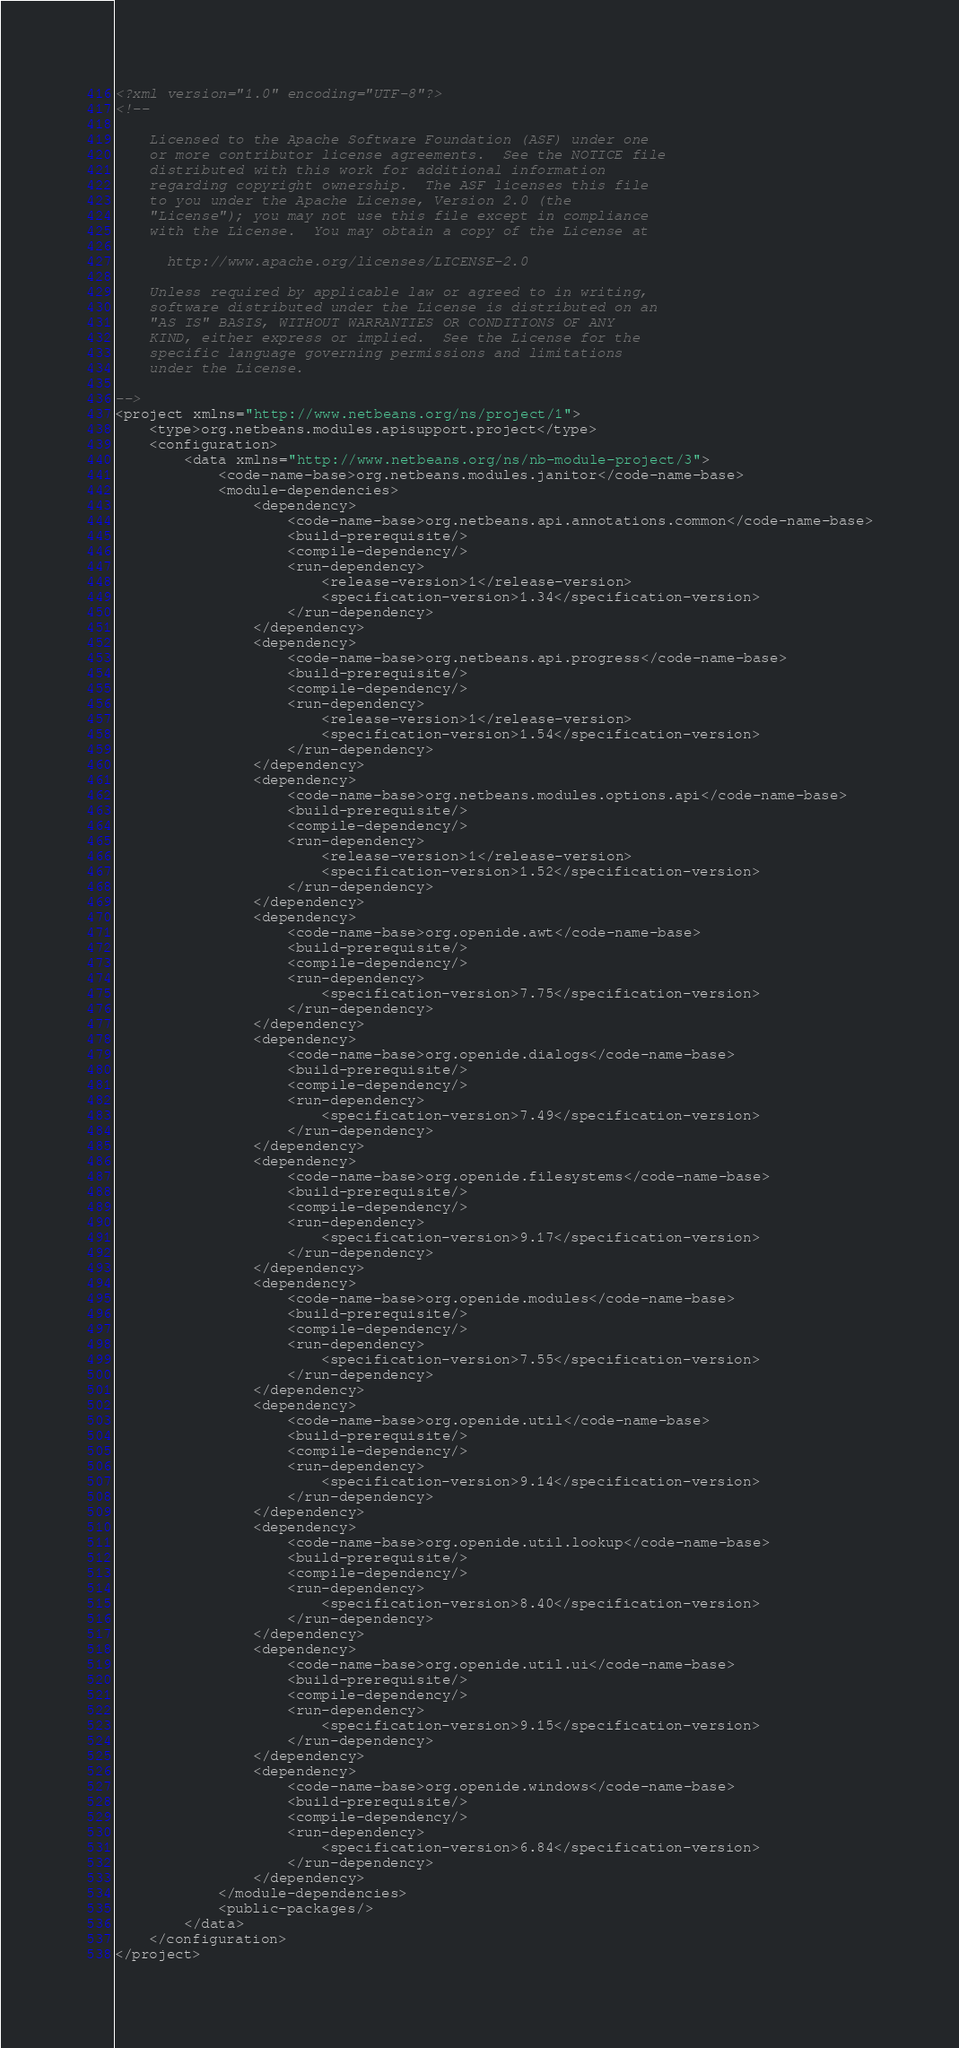<code> <loc_0><loc_0><loc_500><loc_500><_XML_><?xml version="1.0" encoding="UTF-8"?>
<!--

    Licensed to the Apache Software Foundation (ASF) under one
    or more contributor license agreements.  See the NOTICE file
    distributed with this work for additional information
    regarding copyright ownership.  The ASF licenses this file
    to you under the Apache License, Version 2.0 (the
    "License"); you may not use this file except in compliance
    with the License.  You may obtain a copy of the License at

      http://www.apache.org/licenses/LICENSE-2.0

    Unless required by applicable law or agreed to in writing,
    software distributed under the License is distributed on an
    "AS IS" BASIS, WITHOUT WARRANTIES OR CONDITIONS OF ANY
    KIND, either express or implied.  See the License for the
    specific language governing permissions and limitations
    under the License.

-->
<project xmlns="http://www.netbeans.org/ns/project/1">
    <type>org.netbeans.modules.apisupport.project</type>
    <configuration>
        <data xmlns="http://www.netbeans.org/ns/nb-module-project/3">
            <code-name-base>org.netbeans.modules.janitor</code-name-base>
            <module-dependencies>
                <dependency>
                    <code-name-base>org.netbeans.api.annotations.common</code-name-base>
                    <build-prerequisite/>
                    <compile-dependency/>
                    <run-dependency>
                        <release-version>1</release-version>
                        <specification-version>1.34</specification-version>
                    </run-dependency>
                </dependency>
                <dependency>
                    <code-name-base>org.netbeans.api.progress</code-name-base>
                    <build-prerequisite/>
                    <compile-dependency/>
                    <run-dependency>
                        <release-version>1</release-version>
                        <specification-version>1.54</specification-version>
                    </run-dependency>
                </dependency>
                <dependency>
                    <code-name-base>org.netbeans.modules.options.api</code-name-base>
                    <build-prerequisite/>
                    <compile-dependency/>
                    <run-dependency>
                        <release-version>1</release-version>
                        <specification-version>1.52</specification-version>
                    </run-dependency>
                </dependency>
                <dependency>
                    <code-name-base>org.openide.awt</code-name-base>
                    <build-prerequisite/>
                    <compile-dependency/>
                    <run-dependency>
                        <specification-version>7.75</specification-version>
                    </run-dependency>
                </dependency>
                <dependency>
                    <code-name-base>org.openide.dialogs</code-name-base>
                    <build-prerequisite/>
                    <compile-dependency/>
                    <run-dependency>
                        <specification-version>7.49</specification-version>
                    </run-dependency>
                </dependency>
                <dependency>
                    <code-name-base>org.openide.filesystems</code-name-base>
                    <build-prerequisite/>
                    <compile-dependency/>
                    <run-dependency>
                        <specification-version>9.17</specification-version>
                    </run-dependency>
                </dependency>
                <dependency>
                    <code-name-base>org.openide.modules</code-name-base>
                    <build-prerequisite/>
                    <compile-dependency/>
                    <run-dependency>
                        <specification-version>7.55</specification-version>
                    </run-dependency>
                </dependency>
                <dependency>
                    <code-name-base>org.openide.util</code-name-base>
                    <build-prerequisite/>
                    <compile-dependency/>
                    <run-dependency>
                        <specification-version>9.14</specification-version>
                    </run-dependency>
                </dependency>
                <dependency>
                    <code-name-base>org.openide.util.lookup</code-name-base>
                    <build-prerequisite/>
                    <compile-dependency/>
                    <run-dependency>
                        <specification-version>8.40</specification-version>
                    </run-dependency>
                </dependency>
                <dependency>
                    <code-name-base>org.openide.util.ui</code-name-base>
                    <build-prerequisite/>
                    <compile-dependency/>
                    <run-dependency>
                        <specification-version>9.15</specification-version>
                    </run-dependency>
                </dependency>
                <dependency>
                    <code-name-base>org.openide.windows</code-name-base>
                    <build-prerequisite/>
                    <compile-dependency/>
                    <run-dependency>
                        <specification-version>6.84</specification-version>
                    </run-dependency>
                </dependency>
            </module-dependencies>
            <public-packages/>
        </data>
    </configuration>
</project>
</code> 